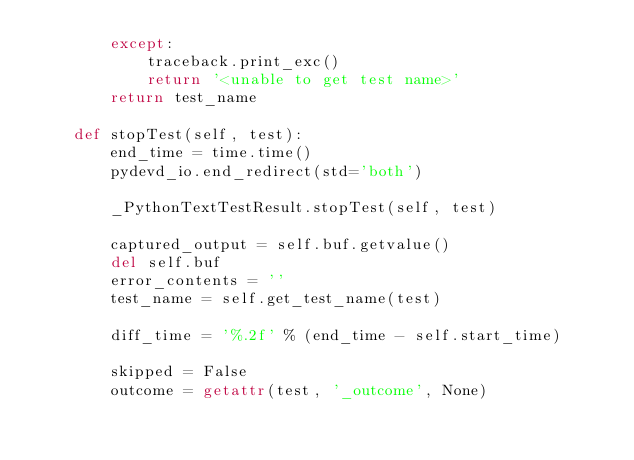Convert code to text. <code><loc_0><loc_0><loc_500><loc_500><_Python_>        except:
            traceback.print_exc()
            return '<unable to get test name>'
        return test_name

    def stopTest(self, test):
        end_time = time.time()
        pydevd_io.end_redirect(std='both')

        _PythonTextTestResult.stopTest(self, test)

        captured_output = self.buf.getvalue()
        del self.buf
        error_contents = ''
        test_name = self.get_test_name(test)

        diff_time = '%.2f' % (end_time - self.start_time)

        skipped = False
        outcome = getattr(test, '_outcome', None)</code> 